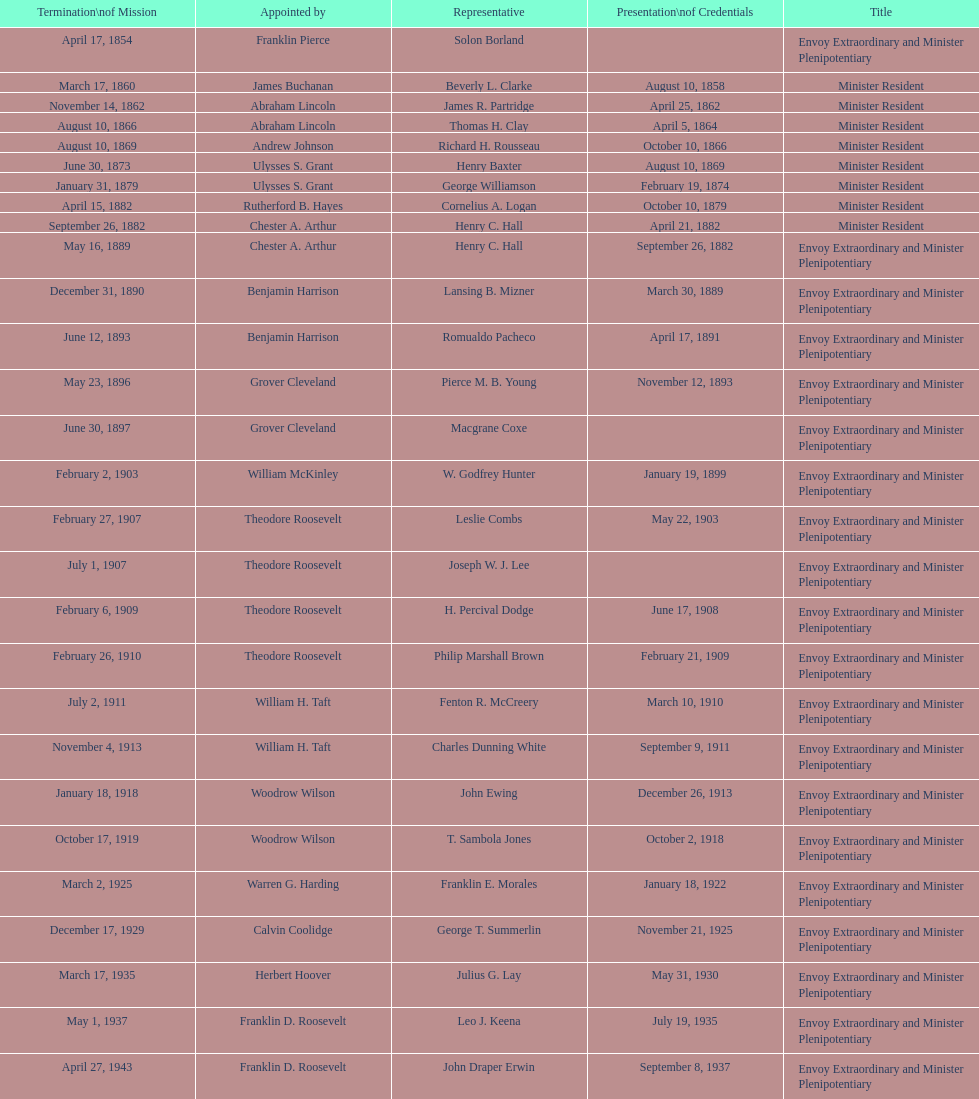Who is the only ambassadors to honduras appointed by barack obama? Lisa Kubiske. 